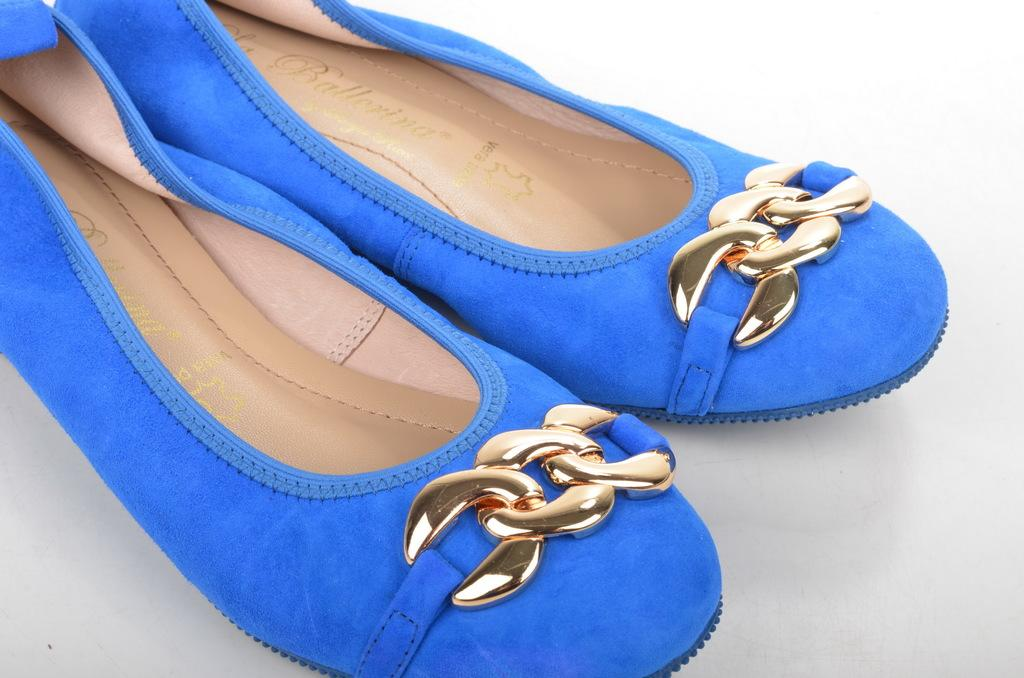What color are the shoes in the image? The shoes in the image are blue. How many kitties are playing with the shoes in the image? There are no kitties present in the image, so it is not possible to determine how many would be playing with the shoes. 